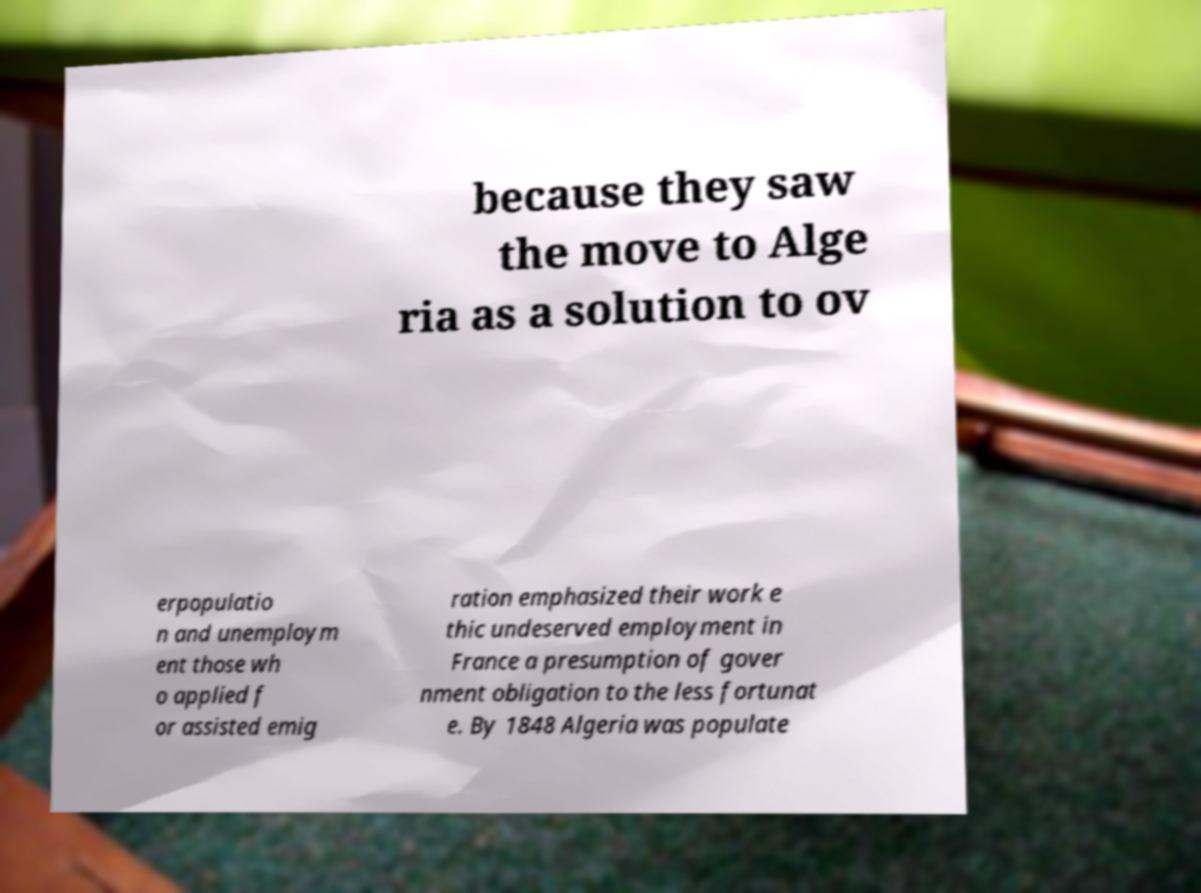What messages or text are displayed in this image? I need them in a readable, typed format. because they saw the move to Alge ria as a solution to ov erpopulatio n and unemploym ent those wh o applied f or assisted emig ration emphasized their work e thic undeserved employment in France a presumption of gover nment obligation to the less fortunat e. By 1848 Algeria was populate 